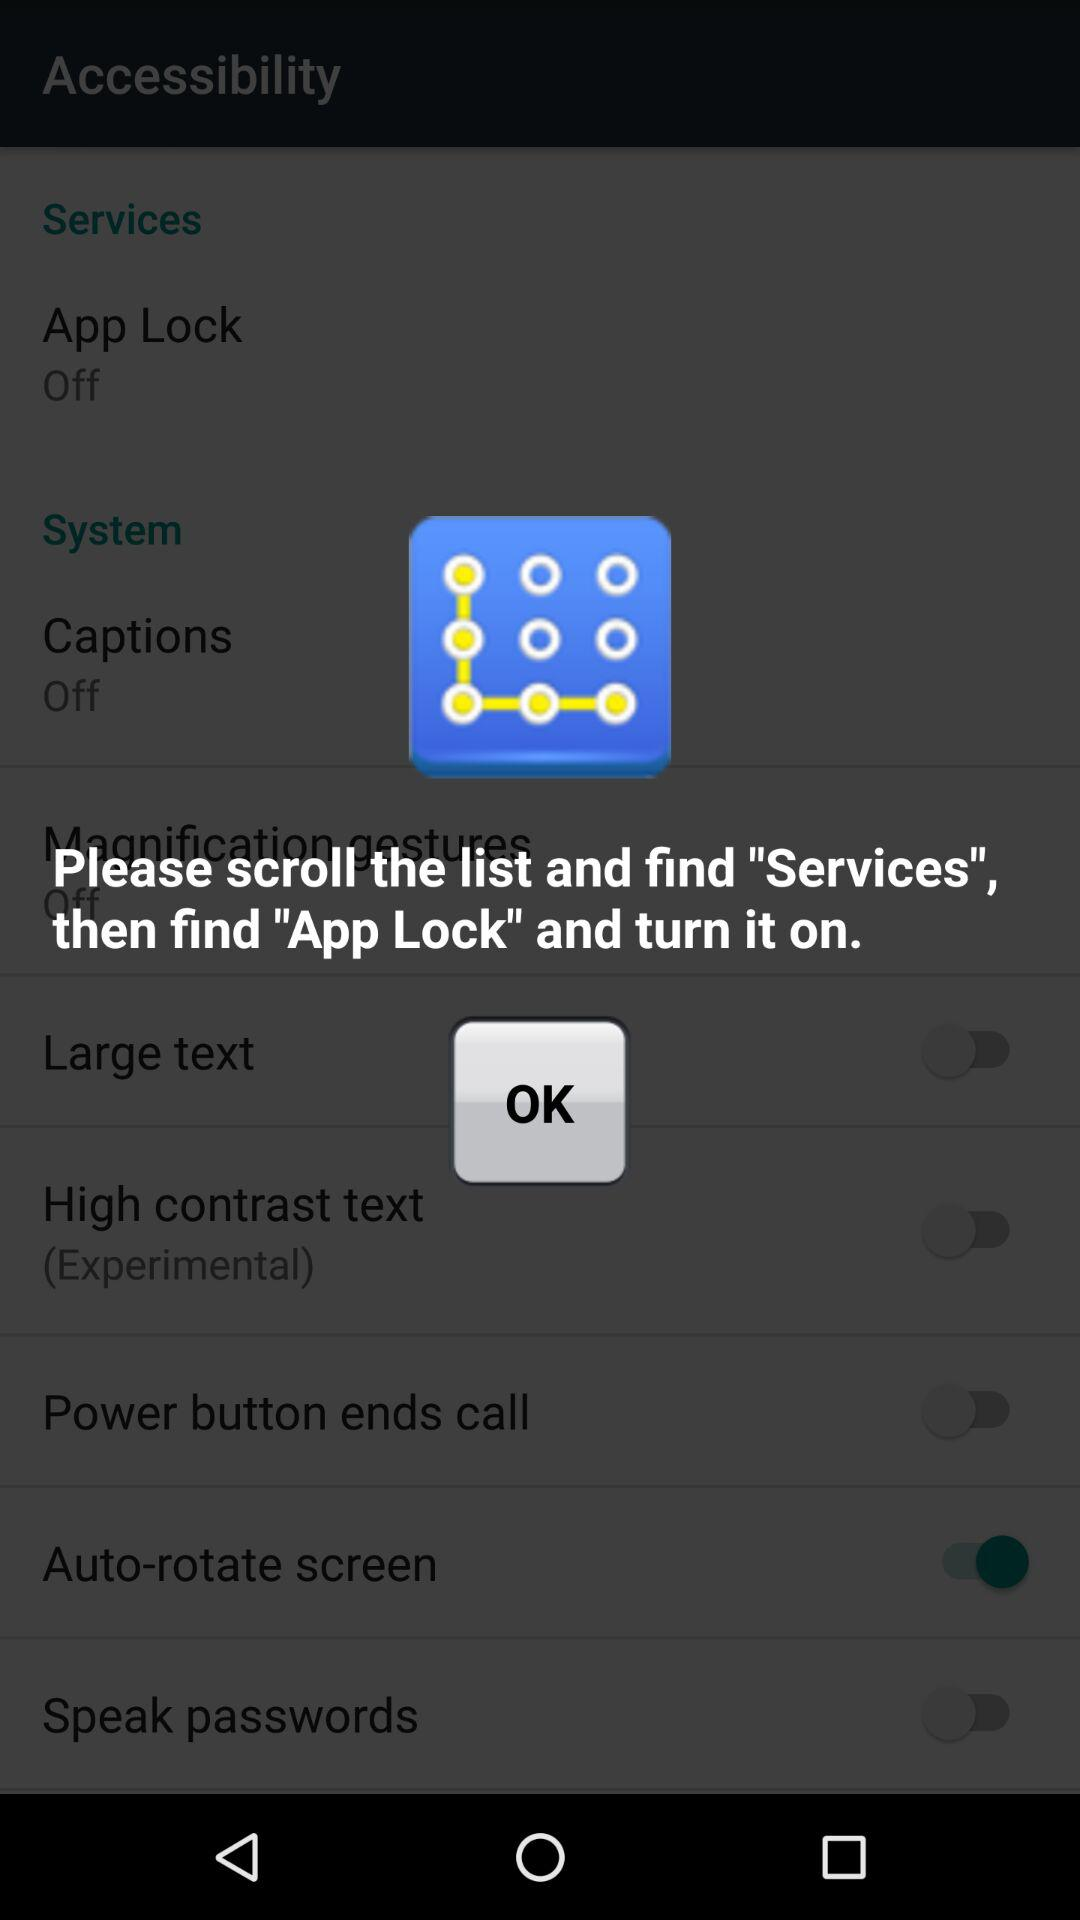What is the application name? The application name is "App protector". 